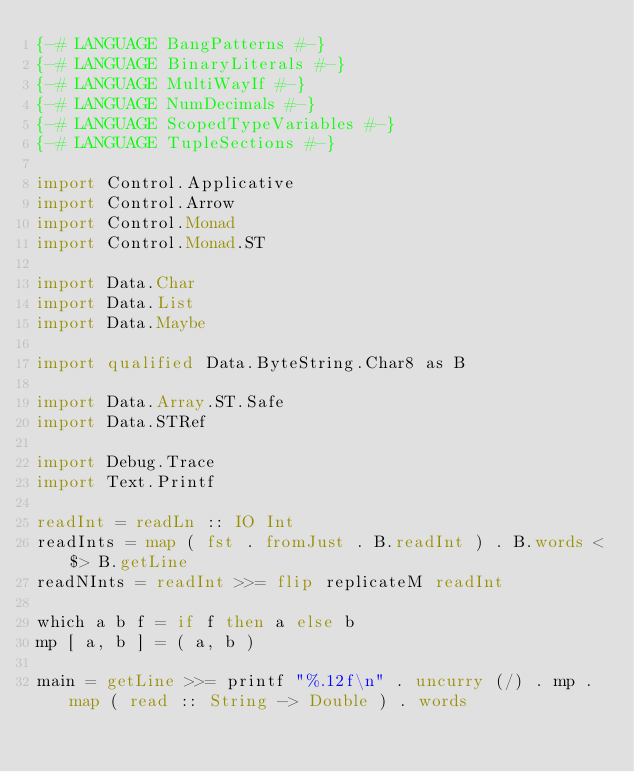<code> <loc_0><loc_0><loc_500><loc_500><_Haskell_>{-# LANGUAGE BangPatterns #-}
{-# LANGUAGE BinaryLiterals #-}
{-# LANGUAGE MultiWayIf #-}
{-# LANGUAGE NumDecimals #-}
{-# LANGUAGE ScopedTypeVariables #-}
{-# LANGUAGE TupleSections #-}

import Control.Applicative
import Control.Arrow
import Control.Monad
import Control.Monad.ST

import Data.Char
import Data.List
import Data.Maybe

import qualified Data.ByteString.Char8 as B

import Data.Array.ST.Safe
import Data.STRef

import Debug.Trace
import Text.Printf

readInt = readLn :: IO Int
readInts = map ( fst . fromJust . B.readInt ) . B.words <$> B.getLine
readNInts = readInt >>= flip replicateM readInt

which a b f = if f then a else b
mp [ a, b ] = ( a, b )

main = getLine >>= printf "%.12f\n" . uncurry (/) . mp . map ( read :: String -> Double ) . words</code> 